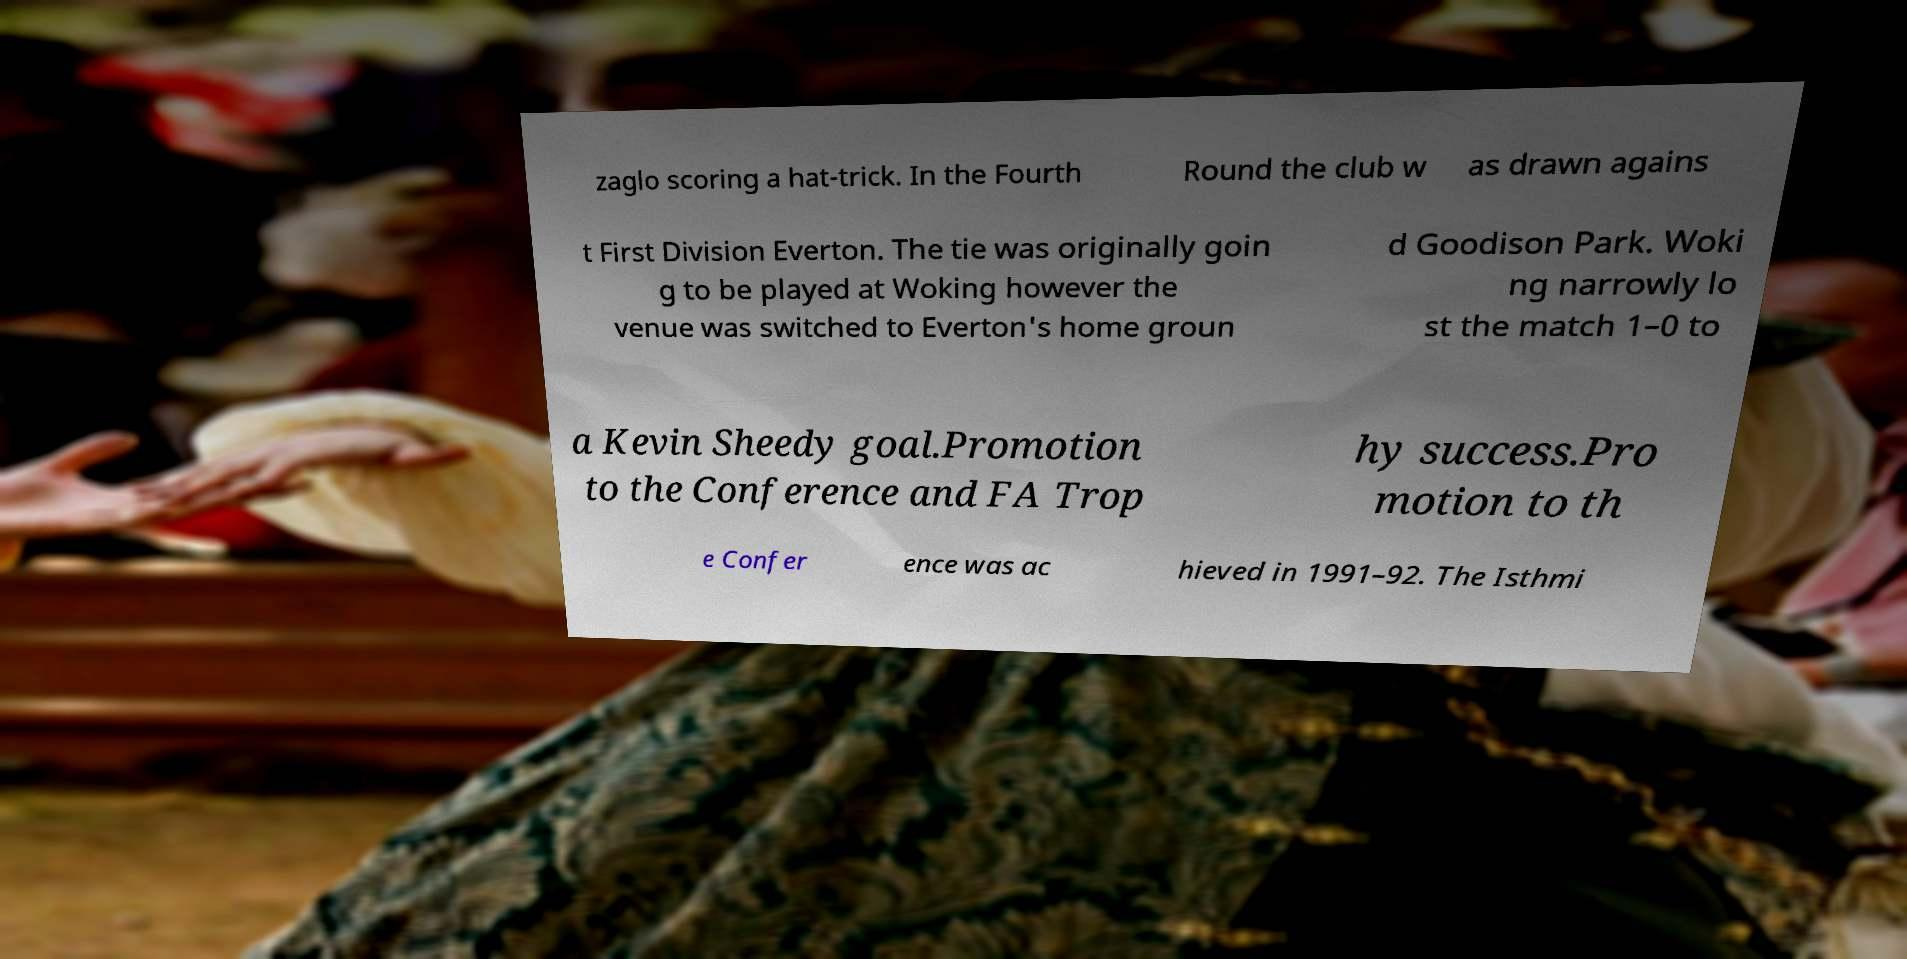For documentation purposes, I need the text within this image transcribed. Could you provide that? zaglo scoring a hat-trick. In the Fourth Round the club w as drawn agains t First Division Everton. The tie was originally goin g to be played at Woking however the venue was switched to Everton's home groun d Goodison Park. Woki ng narrowly lo st the match 1–0 to a Kevin Sheedy goal.Promotion to the Conference and FA Trop hy success.Pro motion to th e Confer ence was ac hieved in 1991–92. The Isthmi 